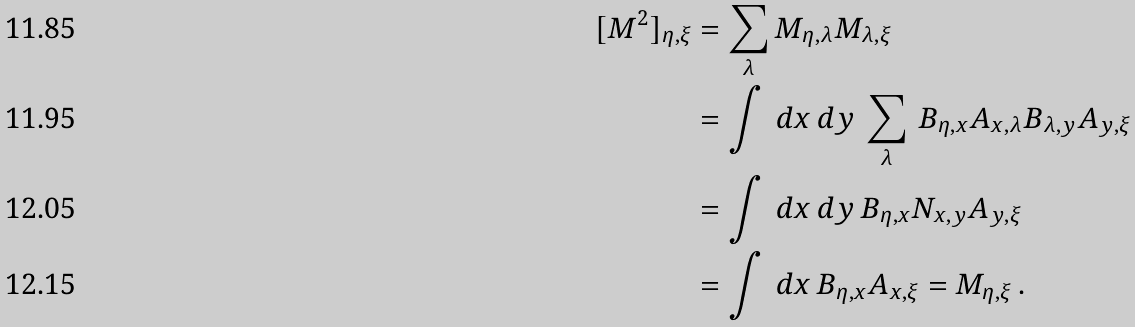<formula> <loc_0><loc_0><loc_500><loc_500>[ M ^ { 2 } ] _ { \eta , \xi } & = \sum _ { \lambda } M _ { \eta , \lambda } M _ { \lambda , \xi } \\ & = \int \, d x \, d y \, \sum _ { \lambda } \, B _ { \eta , x } A _ { x , \lambda } B _ { \lambda , y } A _ { y , \xi } \\ & = \int \, d x \, d y \, B _ { \eta , x } N _ { x , y } A _ { y , \xi } \\ & = \int \, d x \, B _ { \eta , x } A _ { x , \xi } = M _ { \eta , \xi } \, .</formula> 